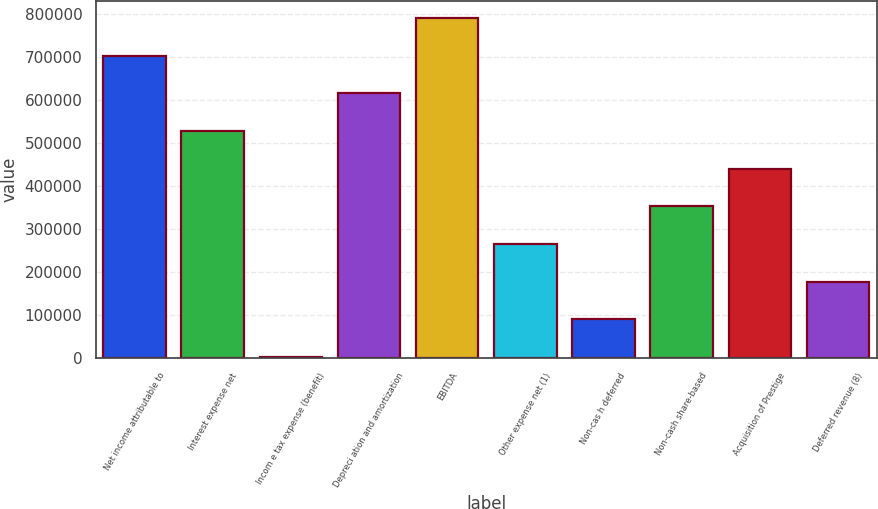<chart> <loc_0><loc_0><loc_500><loc_500><bar_chart><fcel>Net income attributable to<fcel>Interest expense net<fcel>Incom e tax expense (benefit)<fcel>Depreci ation and amortization<fcel>EBITDA<fcel>Other expense net (1)<fcel>Non-cas h deferred<fcel>Non-cash share-based<fcel>Acquisition of Prestige<fcel>Deferred revenue (8)<nl><fcel>702735<fcel>527618<fcel>2267<fcel>615176<fcel>790294<fcel>264942<fcel>89825.5<fcel>352501<fcel>440060<fcel>177384<nl></chart> 